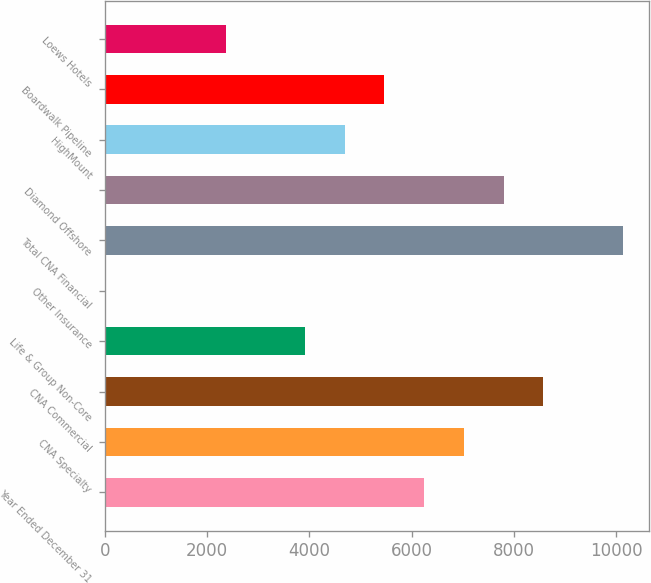Convert chart to OTSL. <chart><loc_0><loc_0><loc_500><loc_500><bar_chart><fcel>Year Ended December 31<fcel>CNA Specialty<fcel>CNA Commercial<fcel>Life & Group Non-Core<fcel>Other Insurance<fcel>Total CNA Financial<fcel>Diamond Offshore<fcel>HighMount<fcel>Boardwalk Pipeline<fcel>Loews Hotels<nl><fcel>6245.2<fcel>7022.1<fcel>8575.9<fcel>3914.5<fcel>30<fcel>10129.7<fcel>7799<fcel>4691.4<fcel>5468.3<fcel>2360.7<nl></chart> 